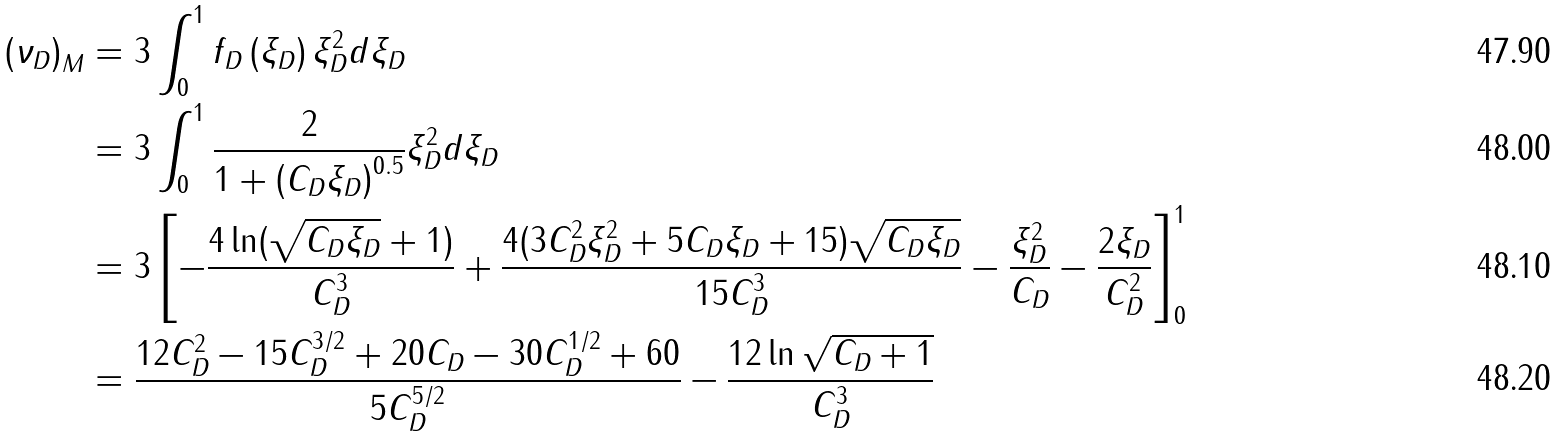<formula> <loc_0><loc_0><loc_500><loc_500>\left ( \nu _ { D } \right ) _ { M } & = 3 \int ^ { 1 } _ { 0 } f _ { D } \left ( \xi _ { D } \right ) \xi ^ { 2 } _ { D } d \xi _ { D } \\ & = 3 \int ^ { 1 } _ { 0 } \frac { 2 } { 1 + \left ( C _ { D } \xi _ { D } \right ) ^ { 0 . 5 } } \xi ^ { 2 } _ { D } d \xi _ { D } \\ & = 3 \left [ - \frac { 4 \ln ( \sqrt { C _ { D } \xi _ { D } } + 1 ) } { C ^ { 3 } _ { D } } + \frac { 4 ( 3 C ^ { 2 } _ { D } \xi ^ { 2 } _ { D } + 5 C _ { D } \xi _ { D } + 1 5 ) \sqrt { C _ { D } \xi _ { D } } } { 1 5 C ^ { 3 } _ { D } } - \frac { \xi ^ { 2 } _ { D } } { C _ { D } } - \frac { 2 \xi _ { D } } { C ^ { 2 } _ { D } } \right ] ^ { 1 } _ { 0 } \\ & = \frac { 1 2 C ^ { 2 } _ { D } - 1 5 C ^ { 3 / 2 } _ { D } + 2 0 C _ { D } - 3 0 C ^ { 1 / 2 } _ { D } + 6 0 } { 5 C ^ { 5 / 2 } _ { D } } - \frac { 1 2 \ln \sqrt { C _ { D } + 1 } } { C ^ { 3 } _ { D } }</formula> 